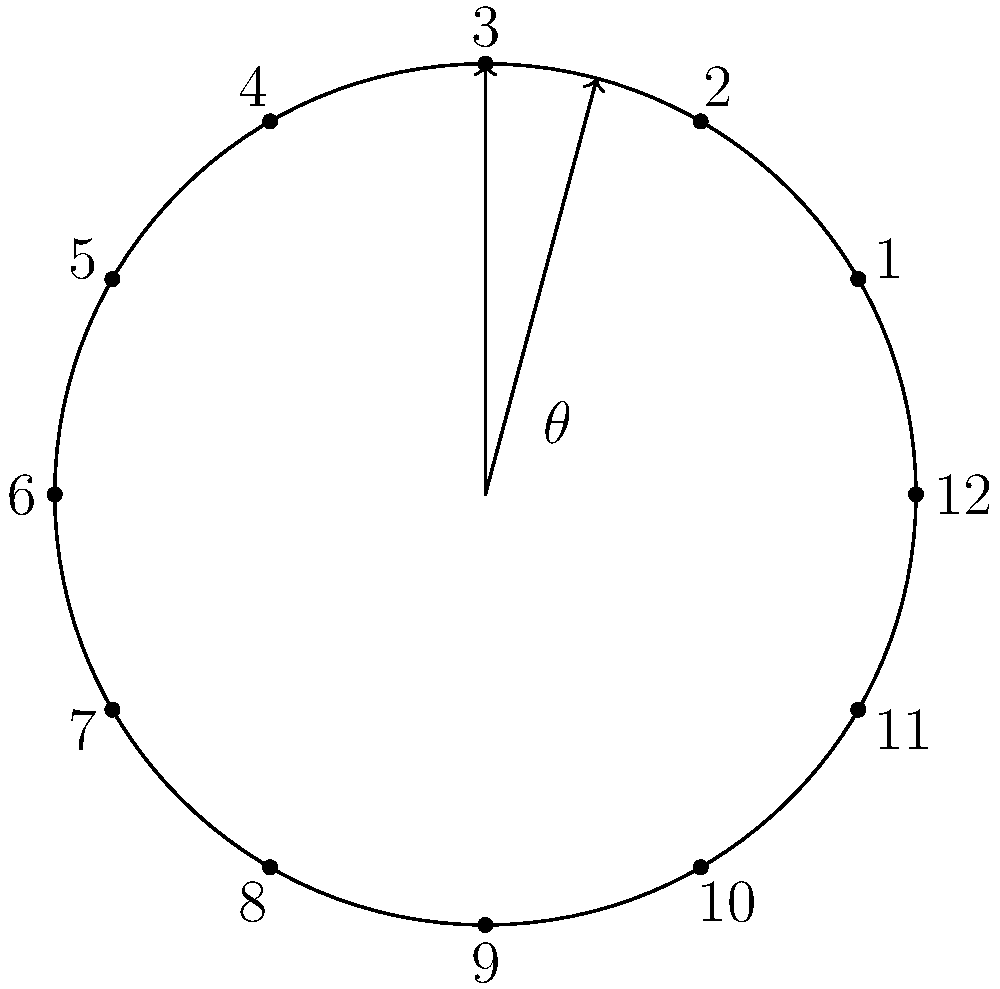Well, look at this! Our mutual friend has been tinkering with clock faces again. They've drawn two lines on this clock, creating an angle $\theta$ between 12 o'clock and 2:30. Can you figure out the measure of $\theta$ in degrees? I bet you can nail this one! Alright, let's work through this together:

1) First, recall that a full rotation around a clock face is 360°.

2) There are 12 hours on a clock face, so each hour mark represents a rotation of:
   $$\frac{360°}{12} = 30°$$

3) The angle between each hour mark is 30°.

4) Now, let's look at the angle we're asked about:
   - It starts at 12 o'clock
   - It ends at 2:30, which is halfway between 2 and 3

5) From 12 to 2 is 2 full hour spaces:
   $$2 \times 30° = 60°$$

6) From 2 to 2:30 is half an hour space:
   $$\frac{1}{2} \times 30° = 15°$$

7) Therefore, the total angle $\theta$ is:
   $$\theta = 60° + 15° = 75°$$

Isn't it fascinating how we can use simple arithmetic to solve geometric problems on a clock face?
Answer: $75°$ 